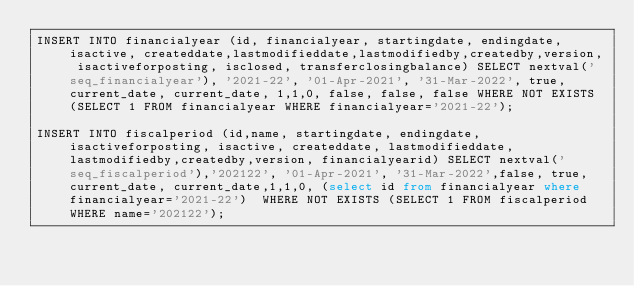Convert code to text. <code><loc_0><loc_0><loc_500><loc_500><_SQL_>INSERT INTO financialyear (id, financialyear, startingdate, endingdate, isactive, createddate,lastmodifieddate,lastmodifiedby,createdby,version, isactiveforposting, isclosed, transferclosingbalance) SELECT nextval('seq_financialyear'), '2021-22', '01-Apr-2021', '31-Mar-2022', true, current_date, current_date, 1,1,0, false, false, false WHERE NOT EXISTS (SELECT 1 FROM financialyear WHERE financialyear='2021-22');

INSERT INTO fiscalperiod (id,name, startingdate, endingdate,isactiveforposting, isactive, createddate, lastmodifieddate,lastmodifiedby,createdby,version, financialyearid) SELECT nextval('seq_fiscalperiod'),'202122', '01-Apr-2021', '31-Mar-2022',false, true, current_date, current_date,1,1,0, (select id from financialyear where financialyear='2021-22')  WHERE NOT EXISTS (SELECT 1 FROM fiscalperiod WHERE name='202122');

</code> 